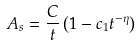Convert formula to latex. <formula><loc_0><loc_0><loc_500><loc_500>A _ { s } = \frac { C } { t } \left ( 1 - c _ { 1 } t ^ { - \eta } \right )</formula> 